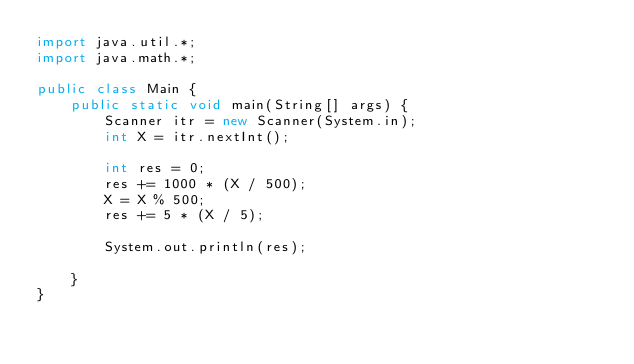Convert code to text. <code><loc_0><loc_0><loc_500><loc_500><_Java_>import java.util.*;
import java.math.*;

public class Main {
    public static void main(String[] args) {
        Scanner itr = new Scanner(System.in);
        int X = itr.nextInt();

        int res = 0;
        res += 1000 * (X / 500);
        X = X % 500;
        res += 5 * (X / 5);

        System.out.println(res);

    }
}
</code> 